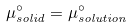Convert formula to latex. <formula><loc_0><loc_0><loc_500><loc_500>\mu _ { s o l i d } ^ { \circ } = \mu _ { s o l u t i o n } ^ { \circ }</formula> 